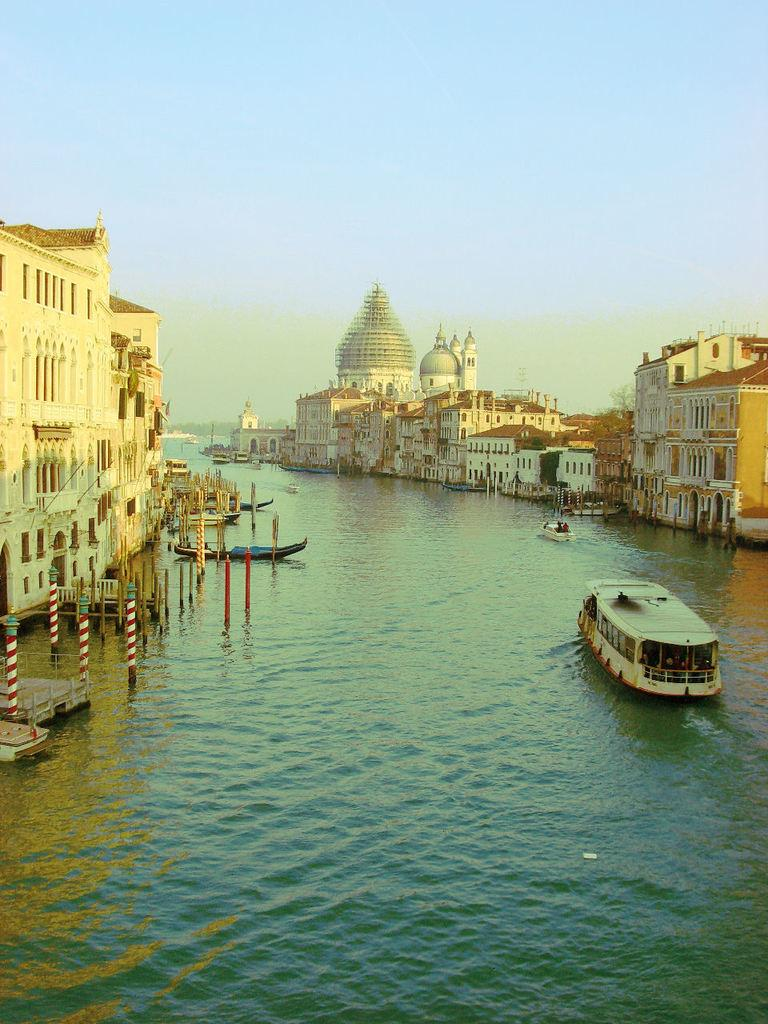What is located on the right side of the image? There is a boat on the right side of the image. What can be seen in the background of the image? The background of the image includes the sky. What type of structures are on the left side of the image? There are buildings on the left side of the image. What type of roof can be seen on the boat in the image? There is no roof present on the boat in the image. How does the boat help the people in the image? The image does not show any people, and therefore it cannot be determined how the boat helps them. 